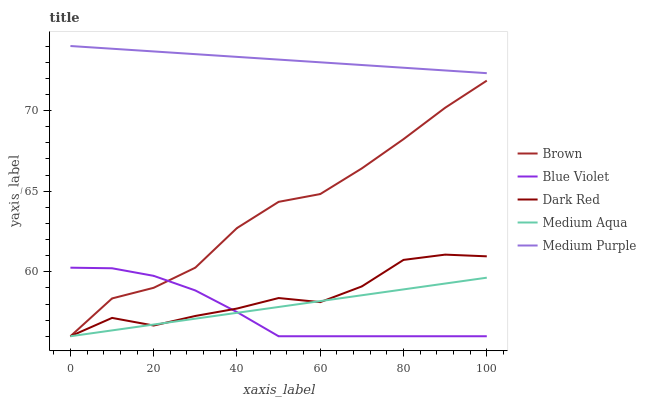Does Blue Violet have the minimum area under the curve?
Answer yes or no. Yes. Does Medium Purple have the maximum area under the curve?
Answer yes or no. Yes. Does Brown have the minimum area under the curve?
Answer yes or no. No. Does Brown have the maximum area under the curve?
Answer yes or no. No. Is Medium Aqua the smoothest?
Answer yes or no. Yes. Is Dark Red the roughest?
Answer yes or no. Yes. Is Brown the smoothest?
Answer yes or no. No. Is Brown the roughest?
Answer yes or no. No. Does Brown have the lowest value?
Answer yes or no. Yes. Does Medium Purple have the highest value?
Answer yes or no. Yes. Does Brown have the highest value?
Answer yes or no. No. Is Dark Red less than Medium Purple?
Answer yes or no. Yes. Is Medium Purple greater than Blue Violet?
Answer yes or no. Yes. Does Blue Violet intersect Brown?
Answer yes or no. Yes. Is Blue Violet less than Brown?
Answer yes or no. No. Is Blue Violet greater than Brown?
Answer yes or no. No. Does Dark Red intersect Medium Purple?
Answer yes or no. No. 